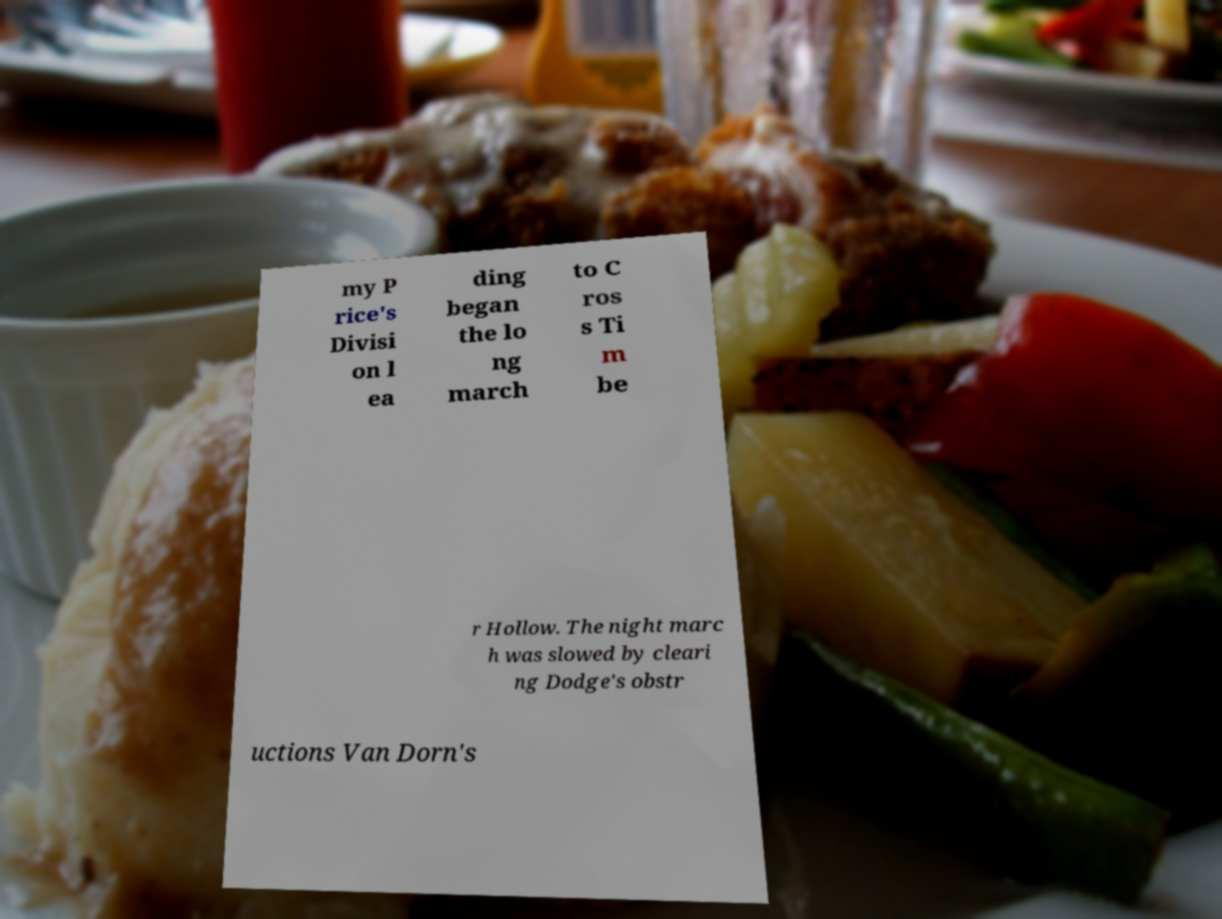I need the written content from this picture converted into text. Can you do that? my P rice's Divisi on l ea ding began the lo ng march to C ros s Ti m be r Hollow. The night marc h was slowed by cleari ng Dodge's obstr uctions Van Dorn's 